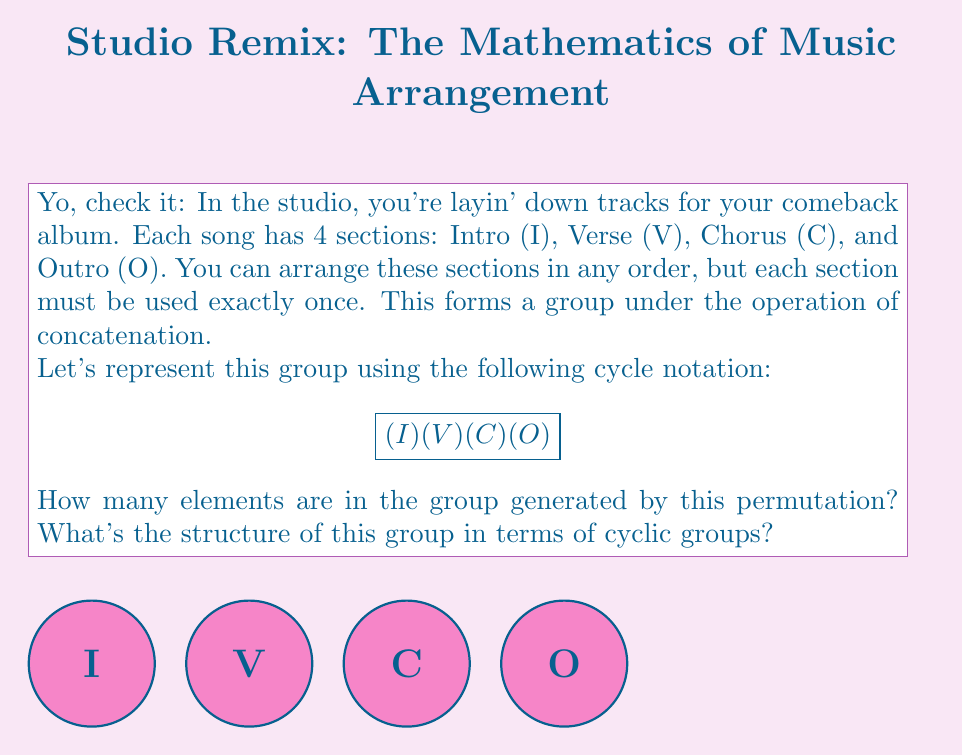Solve this math problem. Aight, let's break this down:

1) First, we need to understand what this permutation means. In cycle notation, $(I)(V)(C)(O)$ represents the identity permutation, where each element maps to itself.

2) The order of an element in a group is the smallest positive integer $n$ such that $a^n = e$ (the identity element). In this case, the order is 1 since $(I)(V)(C)(O)^1 = (I)(V)(C)(O)$.

3) The group generated by this permutation will only contain this single element (the identity permutation).

4) In terms of cyclic groups, this group is isomorphic to the cyclic group of order 1, denoted as $C_1$ or $\mathbb{Z}_1$.

5) The structure of this group can be written as:

   $$\mathbb{Z}_1 \cong \{e\}$$

   where $e$ represents the identity element.

This structure represents the trivial group, which contains only the identity element.
Answer: 1 element; $\mathbb{Z}_1$ 